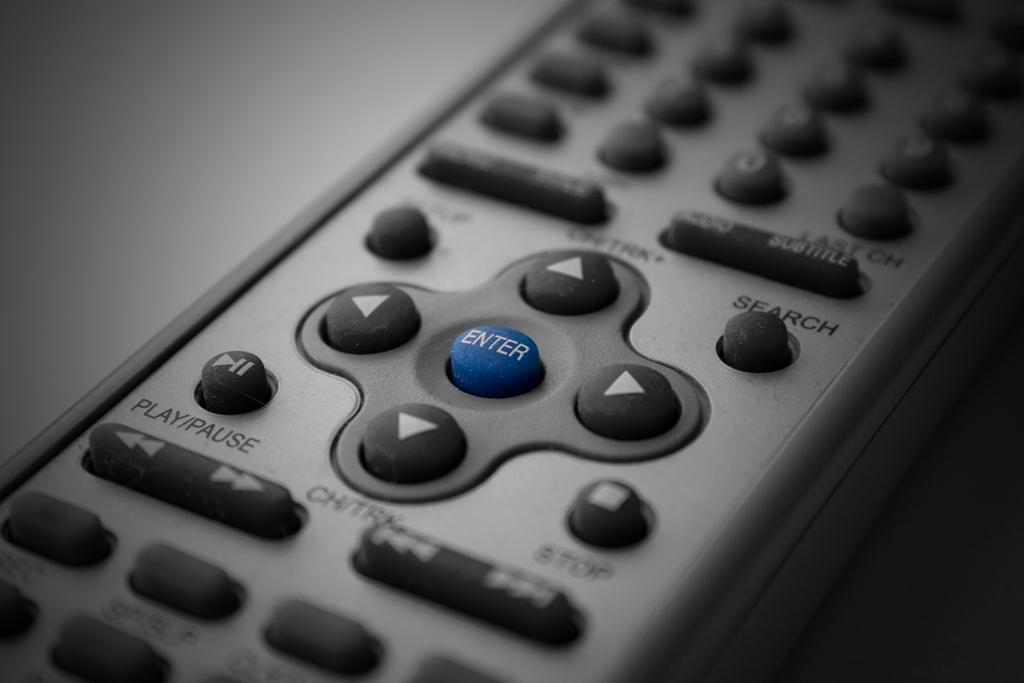<image>
Summarize the visual content of the image. A remote control with a blue enter button in the center. 